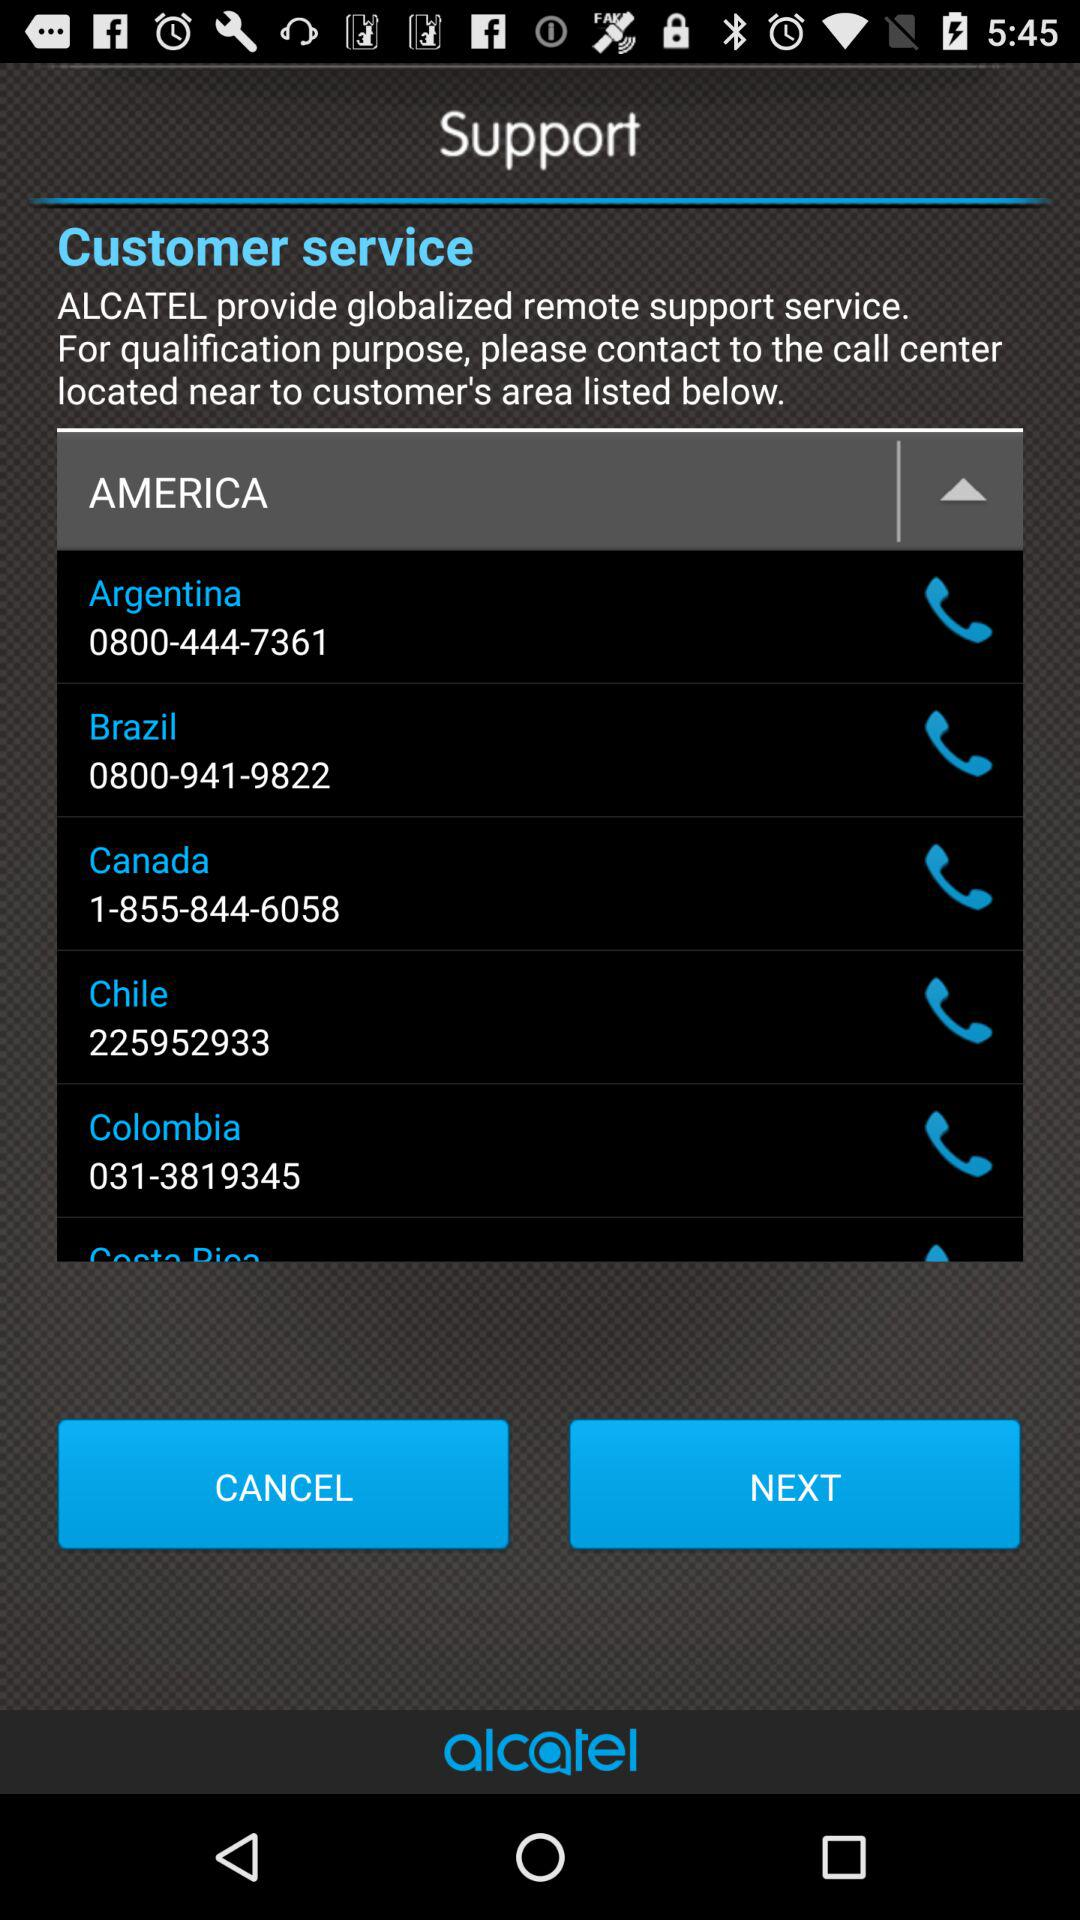What country is the customer service number 031-3819345 for? The customer service number 031-3819345 is for Colombia. 